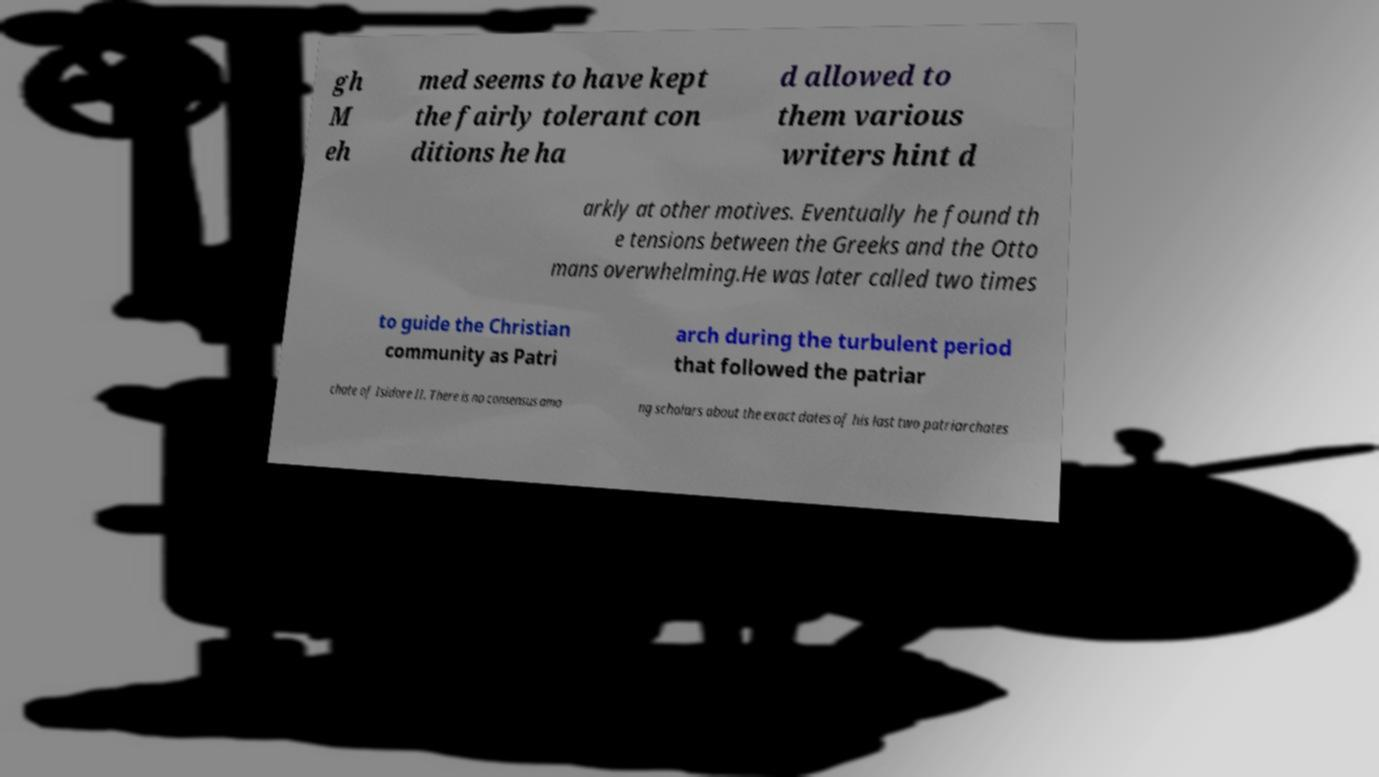Can you accurately transcribe the text from the provided image for me? gh M eh med seems to have kept the fairly tolerant con ditions he ha d allowed to them various writers hint d arkly at other motives. Eventually he found th e tensions between the Greeks and the Otto mans overwhelming.He was later called two times to guide the Christian community as Patri arch during the turbulent period that followed the patriar chate of Isidore II. There is no consensus amo ng scholars about the exact dates of his last two patriarchates 